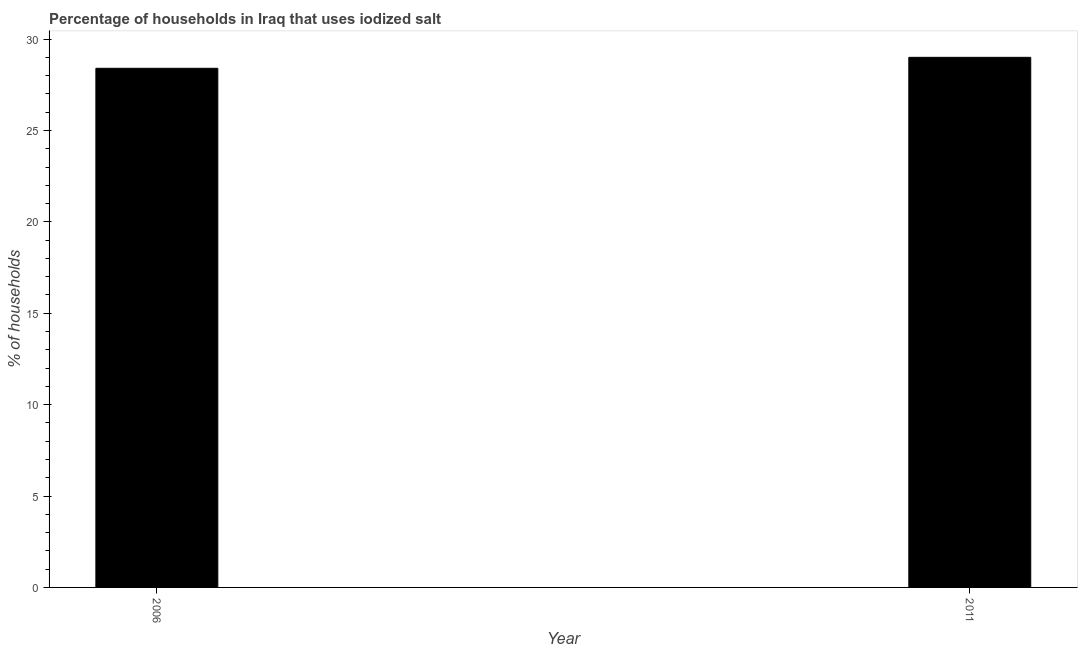Does the graph contain any zero values?
Give a very brief answer. No. Does the graph contain grids?
Your answer should be very brief. No. What is the title of the graph?
Your answer should be very brief. Percentage of households in Iraq that uses iodized salt. What is the label or title of the Y-axis?
Keep it short and to the point. % of households. Across all years, what is the maximum percentage of households where iodized salt is consumed?
Provide a succinct answer. 29. Across all years, what is the minimum percentage of households where iodized salt is consumed?
Keep it short and to the point. 28.4. What is the sum of the percentage of households where iodized salt is consumed?
Offer a terse response. 57.4. What is the difference between the percentage of households where iodized salt is consumed in 2006 and 2011?
Make the answer very short. -0.6. What is the average percentage of households where iodized salt is consumed per year?
Offer a very short reply. 28.7. What is the median percentage of households where iodized salt is consumed?
Your answer should be very brief. 28.7. In how many years, is the percentage of households where iodized salt is consumed greater than 6 %?
Your answer should be compact. 2. In how many years, is the percentage of households where iodized salt is consumed greater than the average percentage of households where iodized salt is consumed taken over all years?
Ensure brevity in your answer.  1. How many years are there in the graph?
Your answer should be very brief. 2. What is the % of households of 2006?
Your response must be concise. 28.4. What is the % of households in 2011?
Make the answer very short. 29. What is the ratio of the % of households in 2006 to that in 2011?
Ensure brevity in your answer.  0.98. 